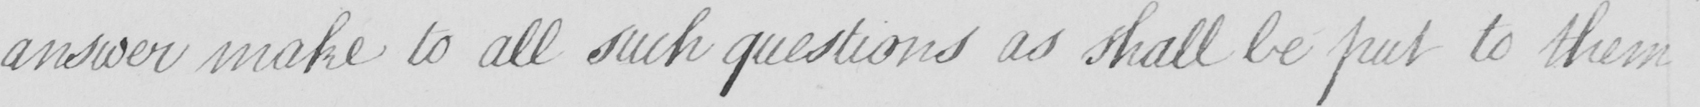What text is written in this handwritten line? answer make to all such questions as shall be put to them 